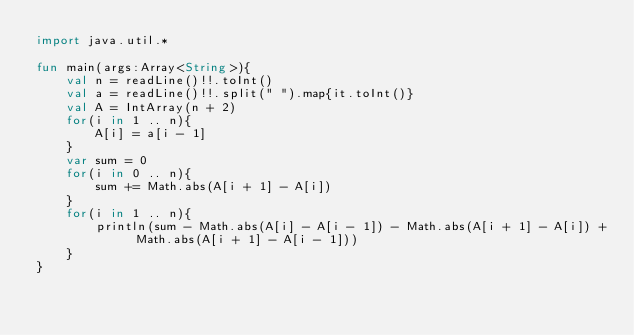Convert code to text. <code><loc_0><loc_0><loc_500><loc_500><_Kotlin_>import java.util.*

fun main(args:Array<String>){
    val n = readLine()!!.toInt()
    val a = readLine()!!.split(" ").map{it.toInt()}
    val A = IntArray(n + 2)
    for(i in 1 .. n){
        A[i] = a[i - 1]
    }
    var sum = 0
    for(i in 0 .. n){
        sum += Math.abs(A[i + 1] - A[i])
    }
    for(i in 1 .. n){
        println(sum - Math.abs(A[i] - A[i - 1]) - Math.abs(A[i + 1] - A[i]) + Math.abs(A[i + 1] - A[i - 1]))
    }
}</code> 